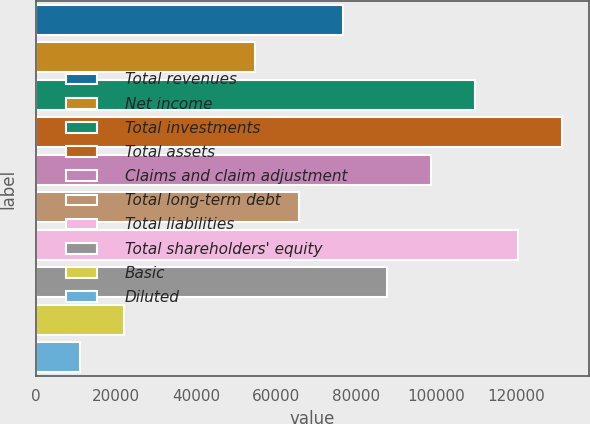Convert chart to OTSL. <chart><loc_0><loc_0><loc_500><loc_500><bar_chart><fcel>Total revenues<fcel>Net income<fcel>Total investments<fcel>Total assets<fcel>Claims and claim adjustment<fcel>Total long-term debt<fcel>Total liabilities<fcel>Total shareholders' equity<fcel>Basic<fcel>Diluted<nl><fcel>76742.8<fcel>54816.6<fcel>109632<fcel>131558<fcel>98668.9<fcel>65779.7<fcel>120595<fcel>87705.8<fcel>21927.3<fcel>10964.3<nl></chart> 